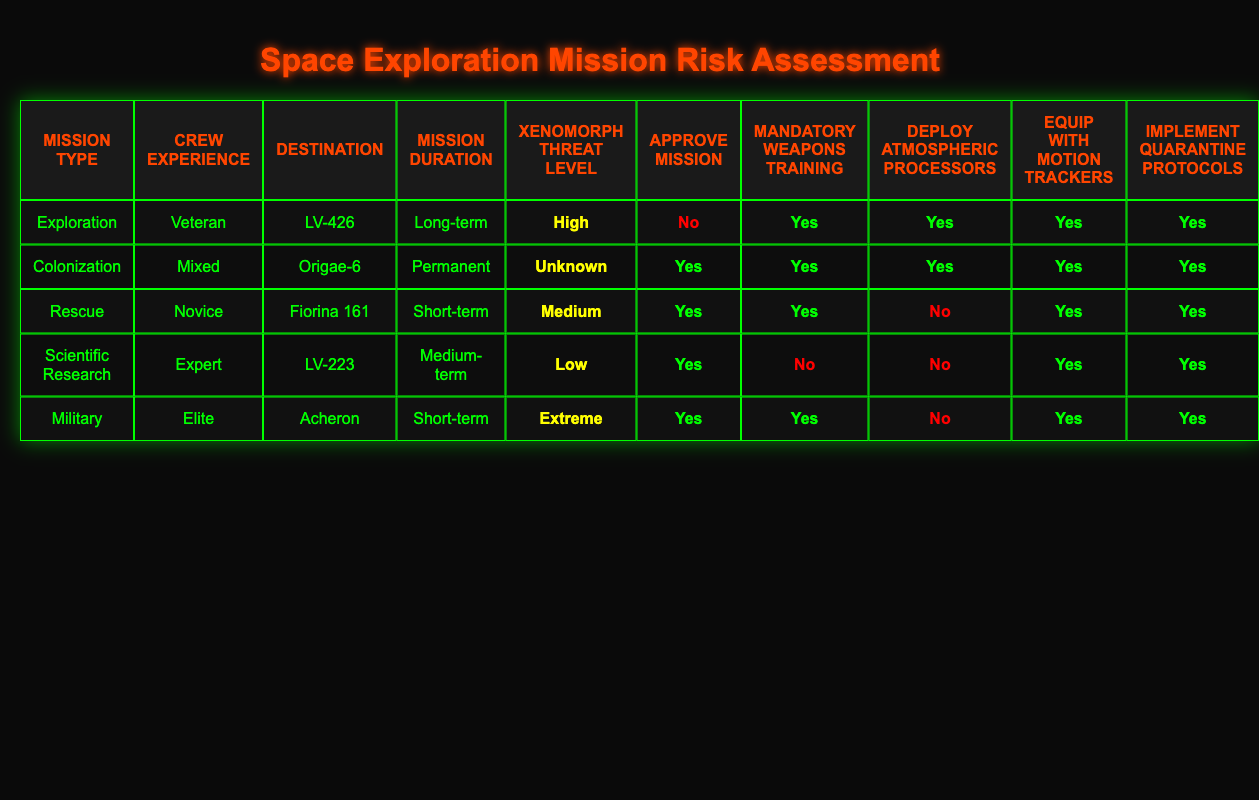What is the destination for the military mission? Looking at the row for the Military mission type, the destination is Acheron.
Answer: Acheron How many missions require mandatory weapons training? The missions requiring mandatory weapons training are Exploration, Colonization, Rescue, Scientific Research, and Military. There are a total of 5 missions with 'Yes' under Mandatory Weapons Training.
Answer: 5 Is the mission to Fiorina 161 approved? The mission row for Fiorina 161 shows 'Yes' under Approve Mission, indicating that this mission is approved.
Answer: Yes Which mission types involve high Xenomorph threat levels? The Exploration mission has a High threat level, whereas the Military mission has an Extreme threat level. Thus, the mission types that involve high threat levels are Exploration and Military.
Answer: Exploration, Military How many mission actions are marked as 'Yes' for the Scientific Research mission? In the Scientific Research mission, the actions marked as 'Yes' are Approve Mission, Equip with Motion Trackers, and Implement Quarantine Protocols. That totals three 'Yes' actions.
Answer: 3 What is the difference in mission durations between the Rescue mission and the Colonization mission? The Rescue mission has a Short-term duration while the Colonization mission has a Permanent duration. This indicates that the Rescue mission is categorized for a limited time compared to the long-term commitment of the Colonization mission.
Answer: Short-term vs Permanent Which mission type has the most extensive crew experience requirement? The Military mission requires the Elite level of crew experience, which is the highest category listed. Hence, the answer is Military.
Answer: Military If a mission has a Medium Xenomorph threat level, what are the actions taken? The Rescue mission, which has a Medium threat level, takes the actions of approving the mission, mandating weapons training, equipping with motion trackers, and implementing quarantine protocols. Deploy Atmospheric Processors is the only 'No' for this mission.
Answer: Approve, Weapons Training, Motion Trackers, Quarantine Can you list the different crew experience levels associated with the different mission types? The mission types and their associated crew experience levels are as follows: Exploration (Veteran), Colonization (Mixed), Rescue (Novice), Scientific Research (Expert), and Military (Elite).
Answer: Veteran, Mixed, Novice, Expert, Elite 